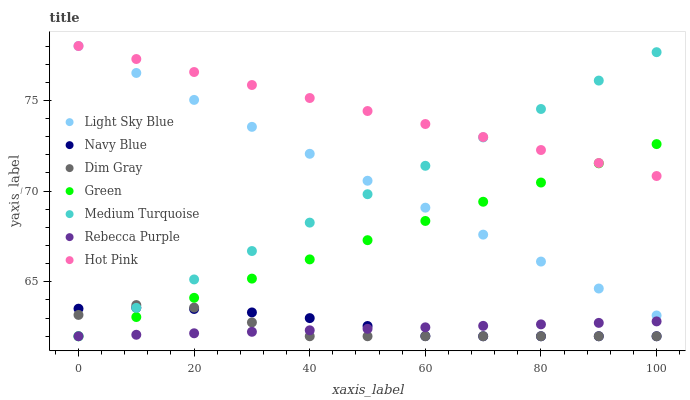Does Rebecca Purple have the minimum area under the curve?
Answer yes or no. Yes. Does Hot Pink have the maximum area under the curve?
Answer yes or no. Yes. Does Navy Blue have the minimum area under the curve?
Answer yes or no. No. Does Navy Blue have the maximum area under the curve?
Answer yes or no. No. Is Light Sky Blue the smoothest?
Answer yes or no. Yes. Is Dim Gray the roughest?
Answer yes or no. Yes. Is Navy Blue the smoothest?
Answer yes or no. No. Is Navy Blue the roughest?
Answer yes or no. No. Does Dim Gray have the lowest value?
Answer yes or no. Yes. Does Hot Pink have the lowest value?
Answer yes or no. No. Does Light Sky Blue have the highest value?
Answer yes or no. Yes. Does Navy Blue have the highest value?
Answer yes or no. No. Is Dim Gray less than Light Sky Blue?
Answer yes or no. Yes. Is Hot Pink greater than Dim Gray?
Answer yes or no. Yes. Does Light Sky Blue intersect Medium Turquoise?
Answer yes or no. Yes. Is Light Sky Blue less than Medium Turquoise?
Answer yes or no. No. Is Light Sky Blue greater than Medium Turquoise?
Answer yes or no. No. Does Dim Gray intersect Light Sky Blue?
Answer yes or no. No. 